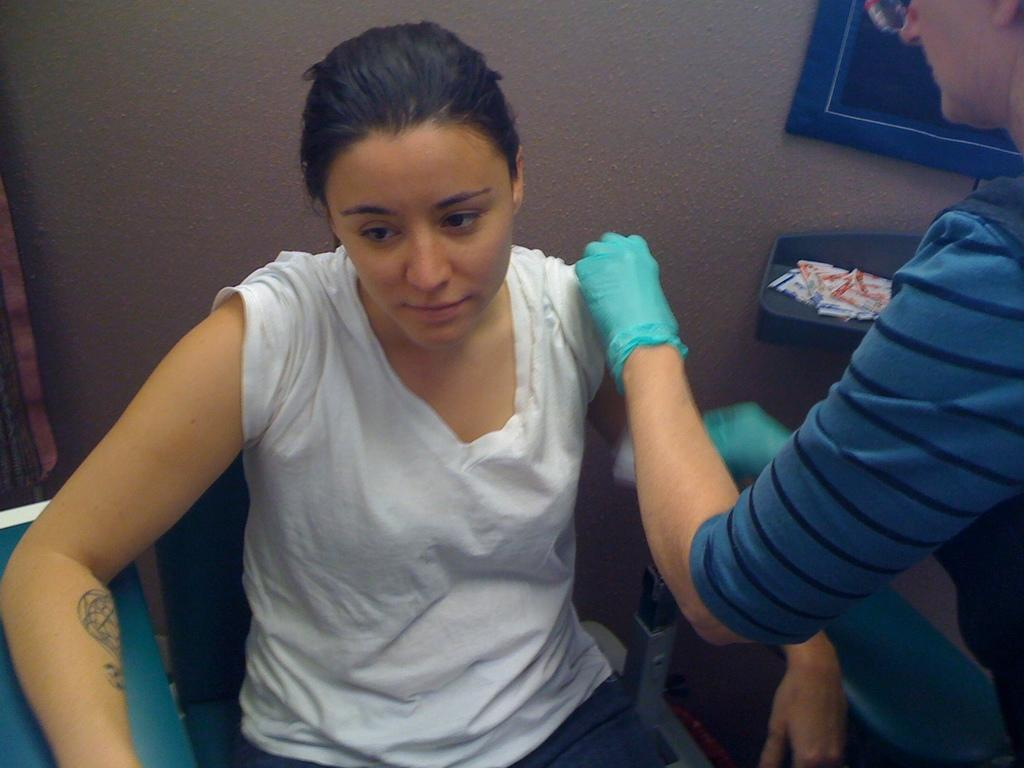What is the woman in the image doing? The woman is sitting on a chair in the image. Can you describe the other person in the image? There is a person standing in the image. What can be seen in the background of the image? There are objects visible in the background of the image, and there is a wall in the background as well. How many planes are flying over the woman in the image? There are no planes visible in the image. 